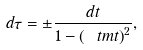Convert formula to latex. <formula><loc_0><loc_0><loc_500><loc_500>d \tau = \pm \frac { d t } { 1 - \left ( \ t m t \right ) ^ { 2 } } ,</formula> 